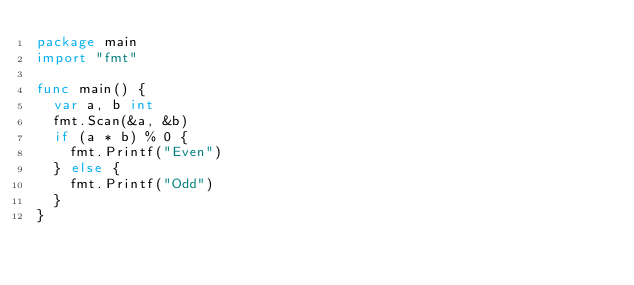<code> <loc_0><loc_0><loc_500><loc_500><_Go_>package main
import "fmt"

func main() {
  var a, b int
  fmt.Scan(&a, &b)
  if (a * b) % 0 {
    fmt.Printf("Even")
  } else {
    fmt.Printf("Odd")
  }
}</code> 